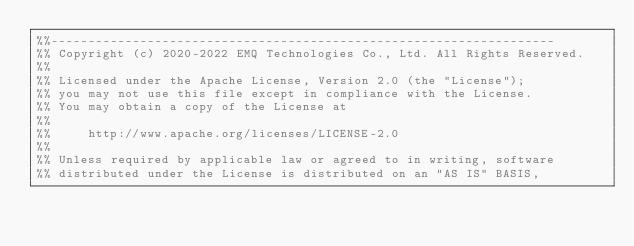Convert code to text. <code><loc_0><loc_0><loc_500><loc_500><_Erlang_>%%--------------------------------------------------------------------
%% Copyright (c) 2020-2022 EMQ Technologies Co., Ltd. All Rights Reserved.
%%
%% Licensed under the Apache License, Version 2.0 (the "License");
%% you may not use this file except in compliance with the License.
%% You may obtain a copy of the License at
%%
%%     http://www.apache.org/licenses/LICENSE-2.0
%%
%% Unless required by applicable law or agreed to in writing, software
%% distributed under the License is distributed on an "AS IS" BASIS,</code> 